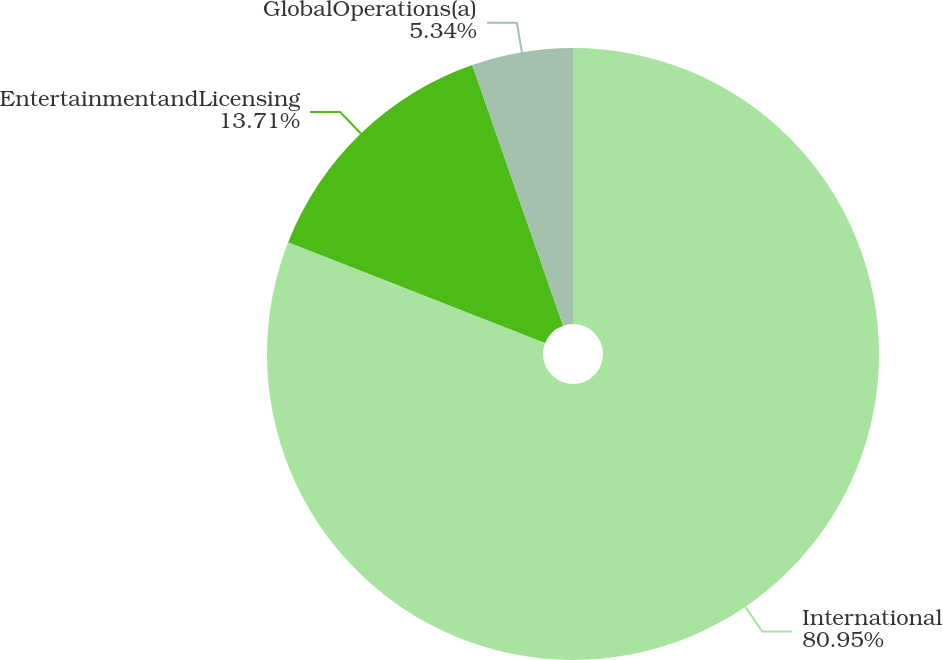<chart> <loc_0><loc_0><loc_500><loc_500><pie_chart><fcel>International<fcel>EntertainmentandLicensing<fcel>GlobalOperations(a)<nl><fcel>80.95%<fcel>13.71%<fcel>5.34%<nl></chart> 